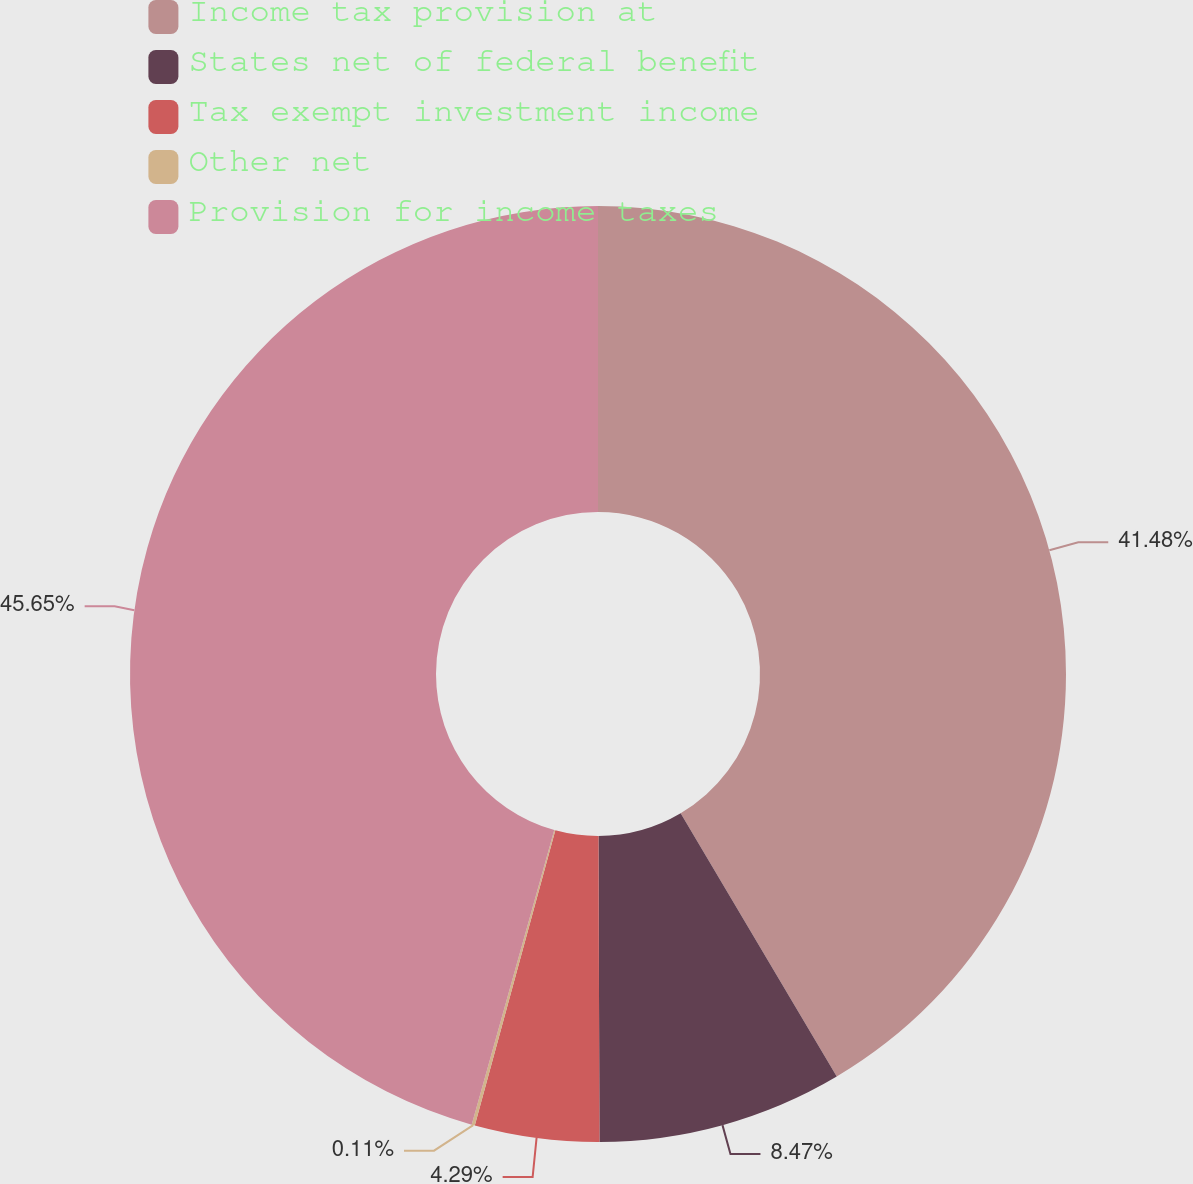<chart> <loc_0><loc_0><loc_500><loc_500><pie_chart><fcel>Income tax provision at<fcel>States net of federal benefit<fcel>Tax exempt investment income<fcel>Other net<fcel>Provision for income taxes<nl><fcel>41.48%<fcel>8.47%<fcel>4.29%<fcel>0.11%<fcel>45.65%<nl></chart> 